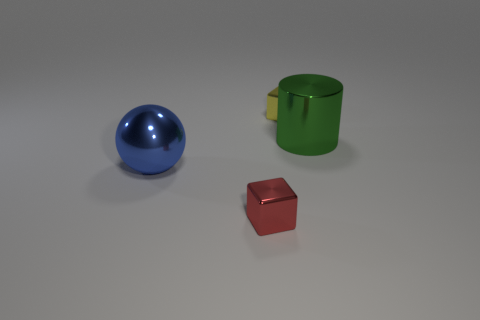Subtract all purple cylinders. How many gray balls are left? 0 Add 4 small red metallic things. How many small red metallic things are left? 5 Add 4 tiny things. How many tiny things exist? 6 Add 4 tiny purple cubes. How many objects exist? 8 Subtract 0 brown blocks. How many objects are left? 4 Subtract all green balls. Subtract all blue cubes. How many balls are left? 1 Subtract all large blue balls. Subtract all blocks. How many objects are left? 1 